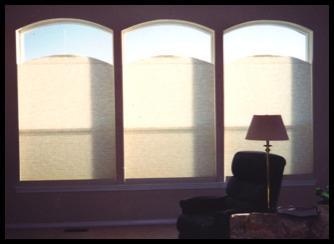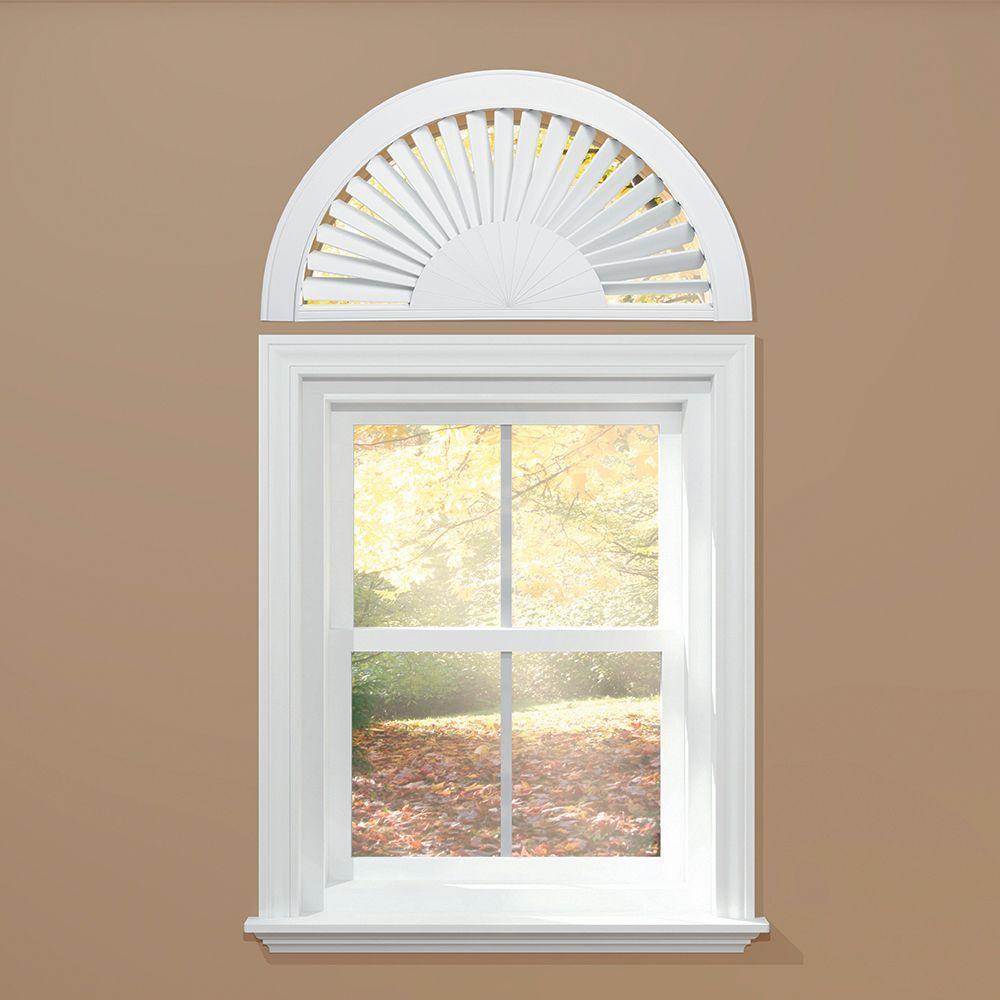The first image is the image on the left, the second image is the image on the right. For the images displayed, is the sentence "There are only two windows visible." factually correct? Answer yes or no. No. The first image is the image on the left, the second image is the image on the right. Examine the images to the left and right. Is the description "There is furniture visible in exactly one image." accurate? Answer yes or no. Yes. 